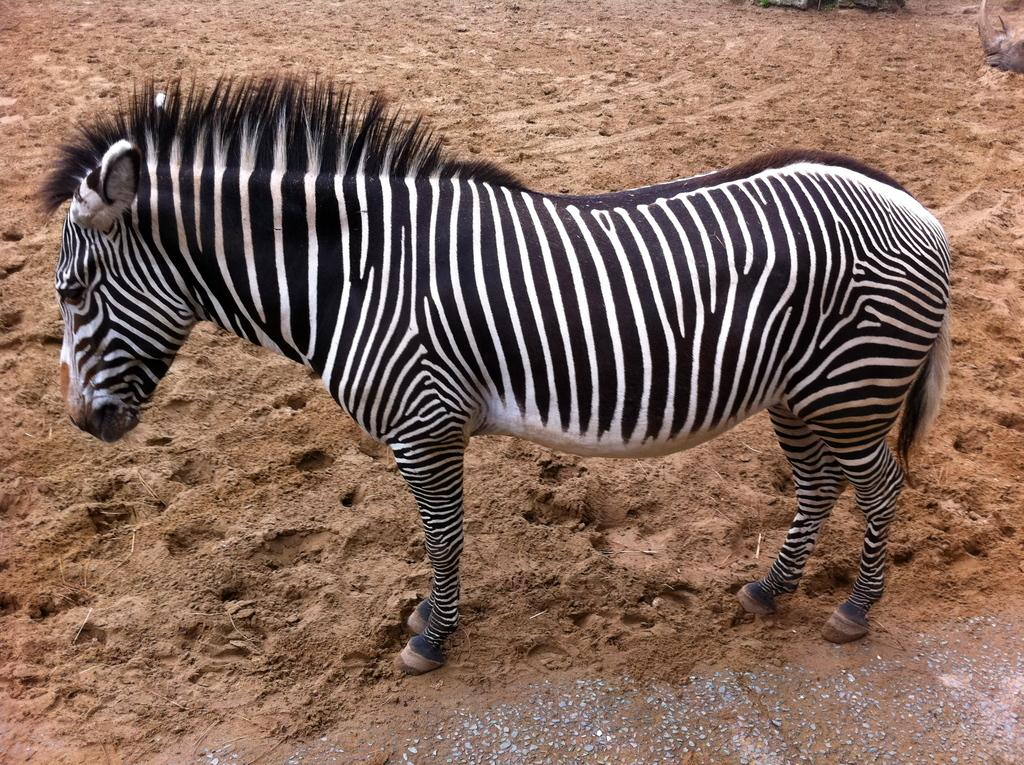What animal is present in the image? There is a zebra in the image. Where is the zebra located? The zebra is on the ground. What type of cough medicine is the zebra using in the image? There is no cough medicine or any indication of a cough in the image; it simply features a zebra on the ground. 